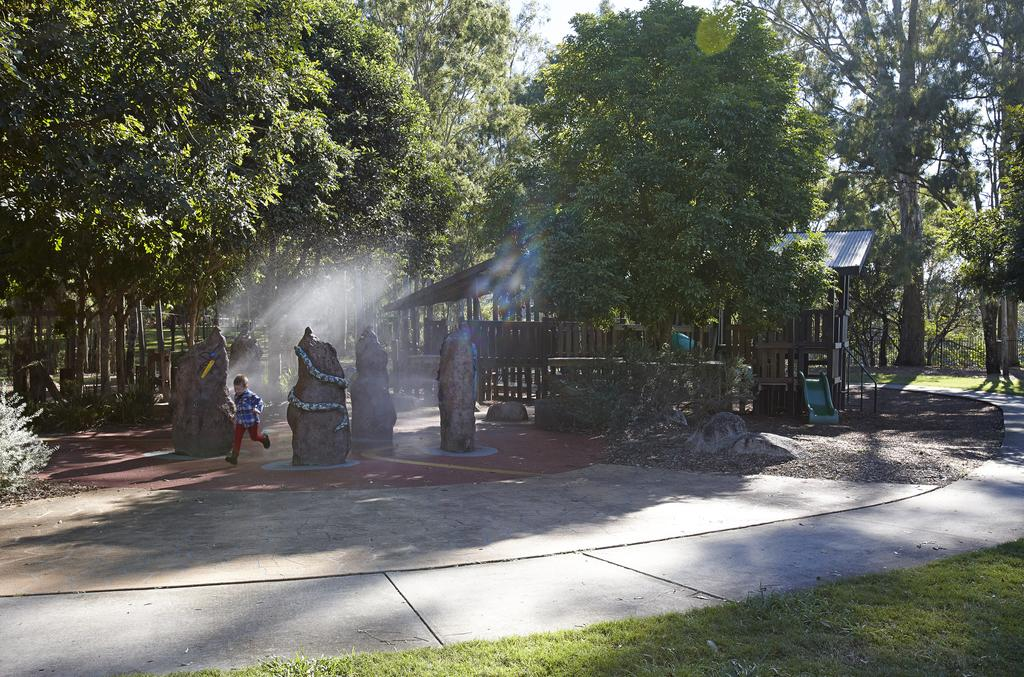What type of vegetation can be seen in the image? There is grass and trees in the image. What structures are present in the image? There is a fence and a tin shed in the image. What other objects can be seen in the image? There are rocks and sliders in the image. What is the boy in the image doing? The boy is running in the image. Where is the boy running in the image? The boy is running on the road in the image. What is visible in the background of the image? The sky is visible in the image. Can you determine the time of day the image was taken? The image appears to be taken during the day. How many geese are flying over the tin shed in the image? There are no geese present in the image. What type of soap is being used to clean the rocks in the image? There is no soap or cleaning activity depicted in the image. 